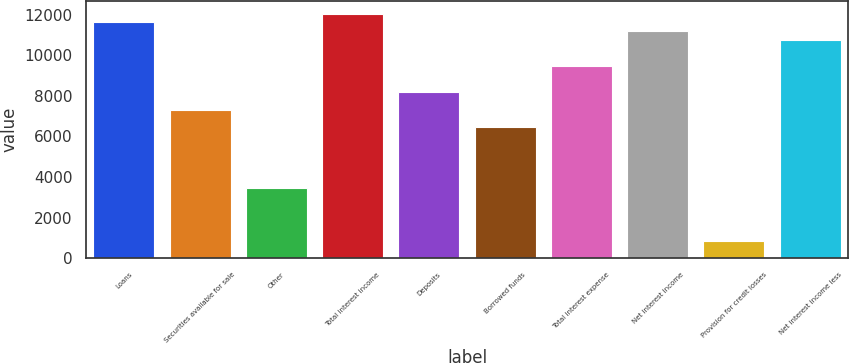Convert chart. <chart><loc_0><loc_0><loc_500><loc_500><bar_chart><fcel>Loans<fcel>Securities available for sale<fcel>Other<fcel>Total interest income<fcel>Deposits<fcel>Borrowed funds<fcel>Total interest expense<fcel>Net interest income<fcel>Provision for credit losses<fcel>Net interest income less<nl><fcel>11618.5<fcel>7317.03<fcel>3445.72<fcel>12048.6<fcel>8177.32<fcel>6456.74<fcel>9467.76<fcel>11188.4<fcel>864.84<fcel>10758.2<nl></chart> 